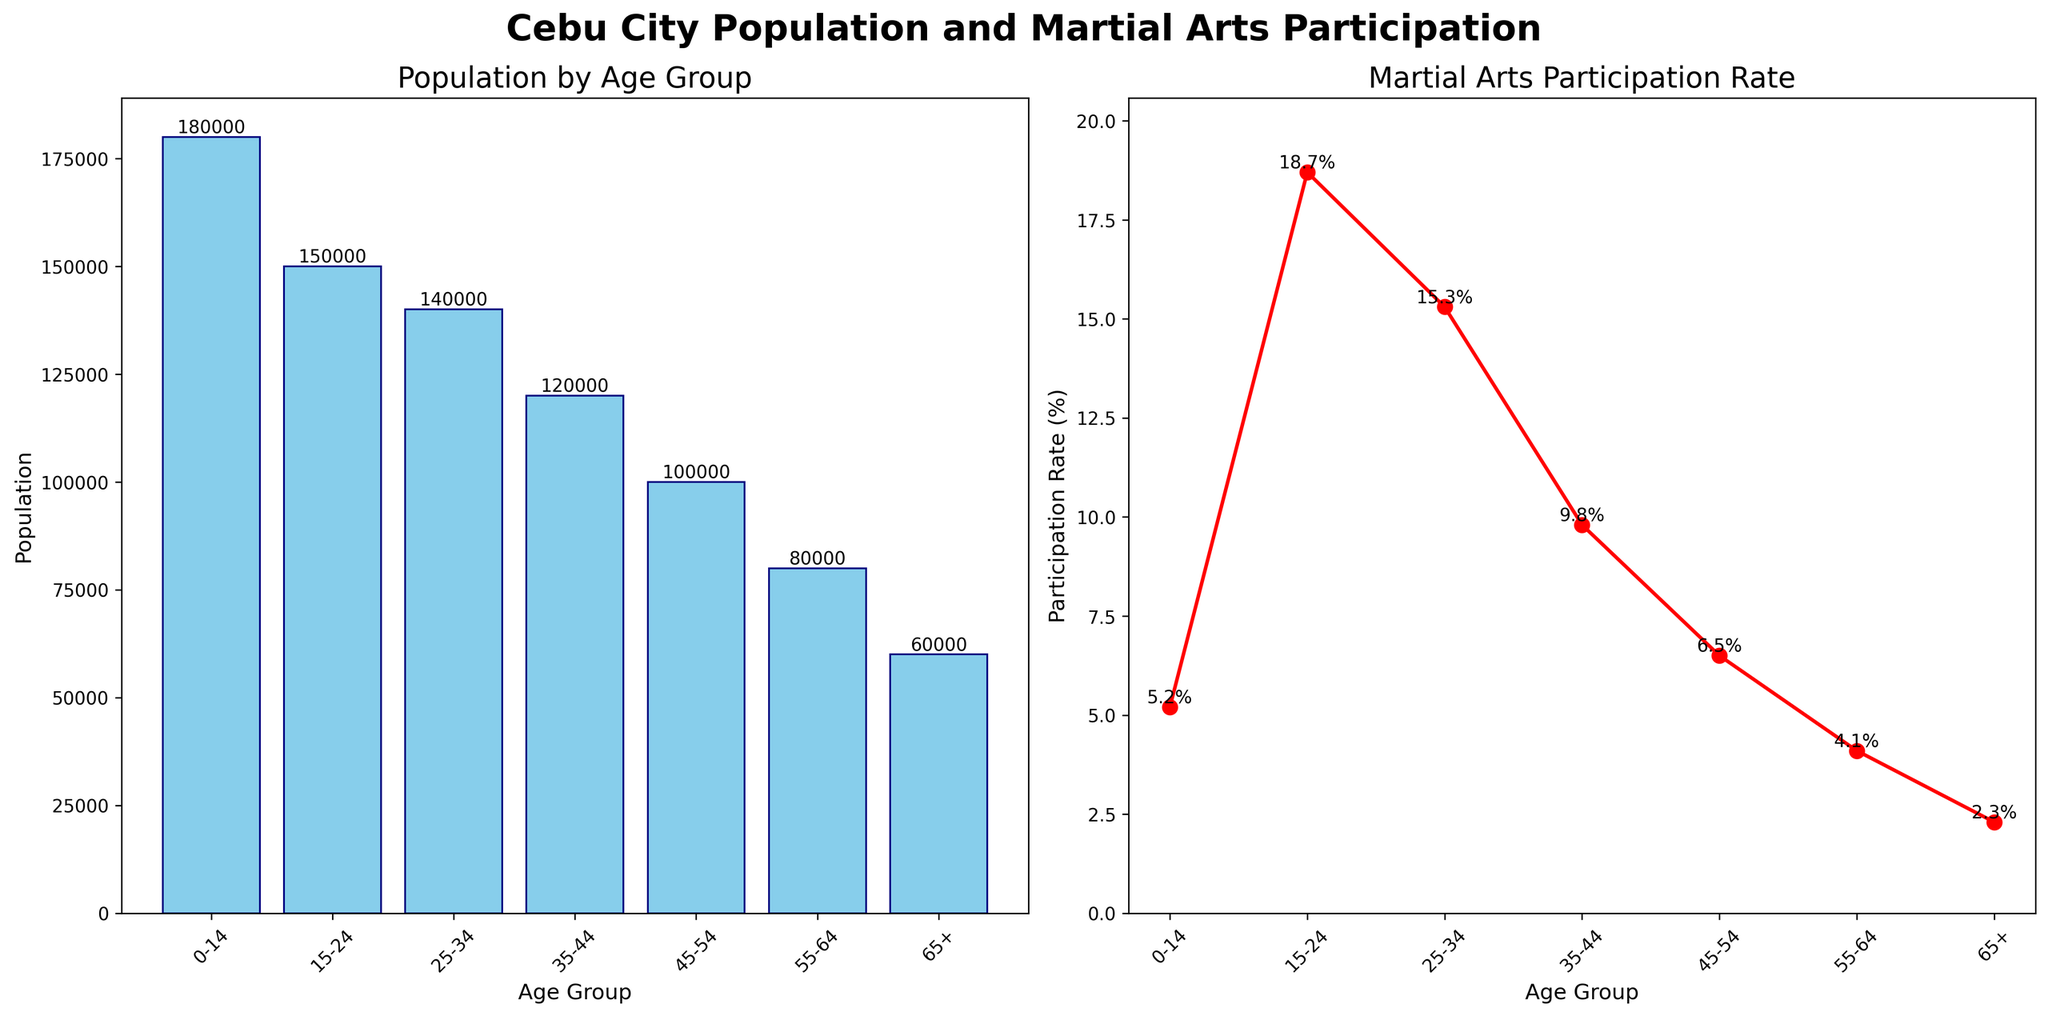Which age group has the highest population? The age group with the highest population has the tallest bar in the "Population by Age Group" plot. The "0-14" age group has the highest population, represented by the tallest bar.
Answer: 0-14 What is the participation rate of the 35-44 age group in martial arts? The "35-44" age group’s participation rate can be found exactly on the line plot in the "Martial Arts Participation Rate" subplot. It is labeled directly above the point.
Answer: 9.8% How much greater is the population of the 25-34 age group than the 65+ age group? The population of the "25-34" age group is 140,000 and that of the "65+" age group is 60,000. Subtract the latter from the former to find the difference. 140,000 - 60,000 = 80,000.
Answer: 80,000 Which age group shows the highest martial arts participation rate? Look for the highest point on the "Martial Arts Participation Rate" line plot. The "15-24" age group shows the highest participation rate at 18.7%.
Answer: 15-24 What is the total population of the age groups listed in the plot? Sum the population values of all age groups: 180,000 + 150,000 + 140,000 + 120,000 + 100,000 + 80,000 + 60,000. The total is 830,000.
Answer: 830,000 How many age groups have a participation rate greater than 10%? From the line plot, observe and count the age groups whose participation rates are above 10%. The "15-24" (18.7%) and "25-34" (15.3%) age groups meet this criterion. Thus, there are 2 age groups.
Answer: 2 Which age group has the lowest population? The group with the shortest bar in the "Population by Age Group" plot has the lowest population. The "65+" age group has the shortest bar indicating the lowest population.
Answer: 65+ What is the average martial arts participation rate across all age groups? Sum all the participation rates and divide by the number of age groups: (5.2 + 18.7 + 15.3 + 9.8 + 6.5 + 4.1 + 2.3) / 7. The total is 61.9, so the average is 61.9 / 7 ≈ 8.84%.
Answer: 8.84% Which age group has a participation rate closest to 10%? On the line plot, the "35-44" age group's participation rate is closest to 10%, standing at 9.8%.
Answer: 35-44 Is the participation rate higher in the 45-54 age group or the 55-64 age group? By comparing the points on the participation rate line plot, the "45-54" age group has a rate of 6.5% while the "55-64" group has 4.1%. Therefore, the participation rate is higher in the "45-54" age group.
Answer: 45-54 